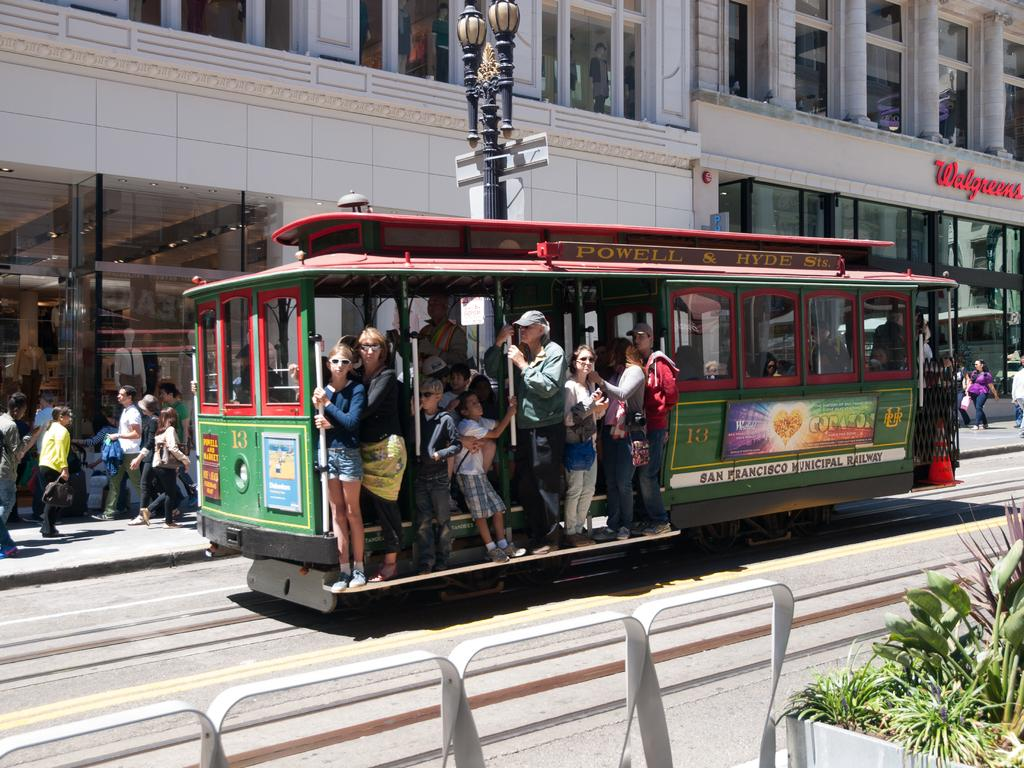Provide a one-sentence caption for the provided image. San Francisco runs a system of street trolleys. 